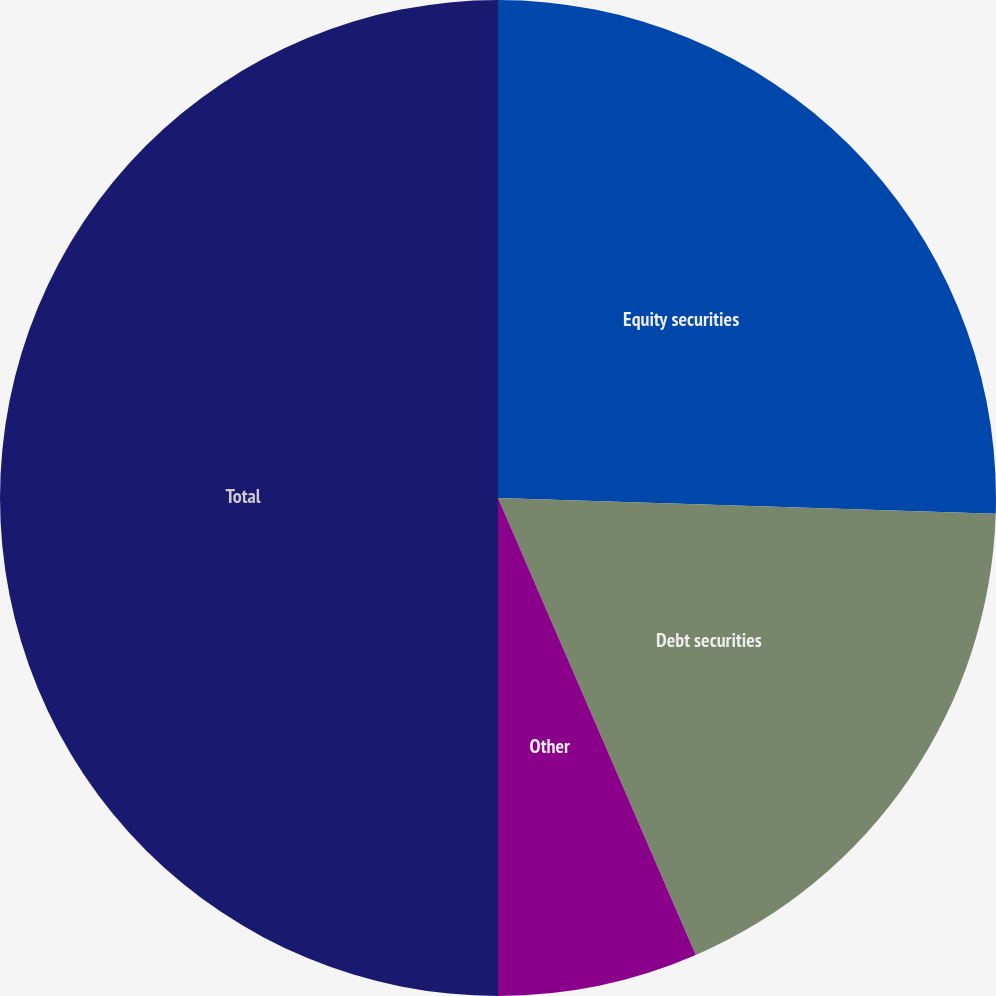Convert chart. <chart><loc_0><loc_0><loc_500><loc_500><pie_chart><fcel>Equity securities<fcel>Debt securities<fcel>Other<fcel>Total<nl><fcel>25.5%<fcel>18.0%<fcel>6.5%<fcel>50.0%<nl></chart> 